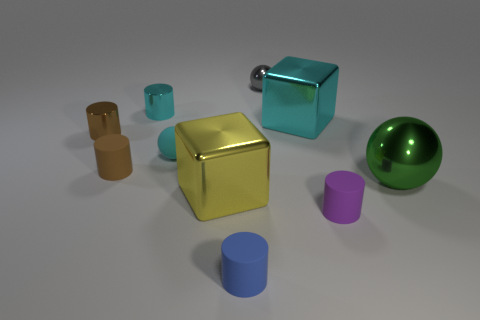There is a cube that is the same color as the tiny rubber ball; what is its size?
Your response must be concise. Large. What number of objects are matte cylinders on the left side of the blue object or big cyan rubber objects?
Your answer should be compact. 1. Is there a gray metallic ball of the same size as the brown matte thing?
Your response must be concise. Yes. How many things are behind the small purple rubber thing and in front of the gray ball?
Offer a very short reply. 7. There is a cyan sphere; what number of shiny things are in front of it?
Provide a short and direct response. 2. Is there a tiny purple thing that has the same shape as the brown rubber thing?
Your answer should be very brief. Yes. There is a large yellow metallic thing; is its shape the same as the tiny purple matte thing to the left of the green metallic object?
Give a very brief answer. No. How many cylinders are small metal things or brown metal objects?
Offer a very short reply. 2. There is a tiny shiny object that is to the right of the blue matte object; what shape is it?
Your answer should be compact. Sphere. How many tiny purple objects have the same material as the large cyan cube?
Your answer should be compact. 0. 